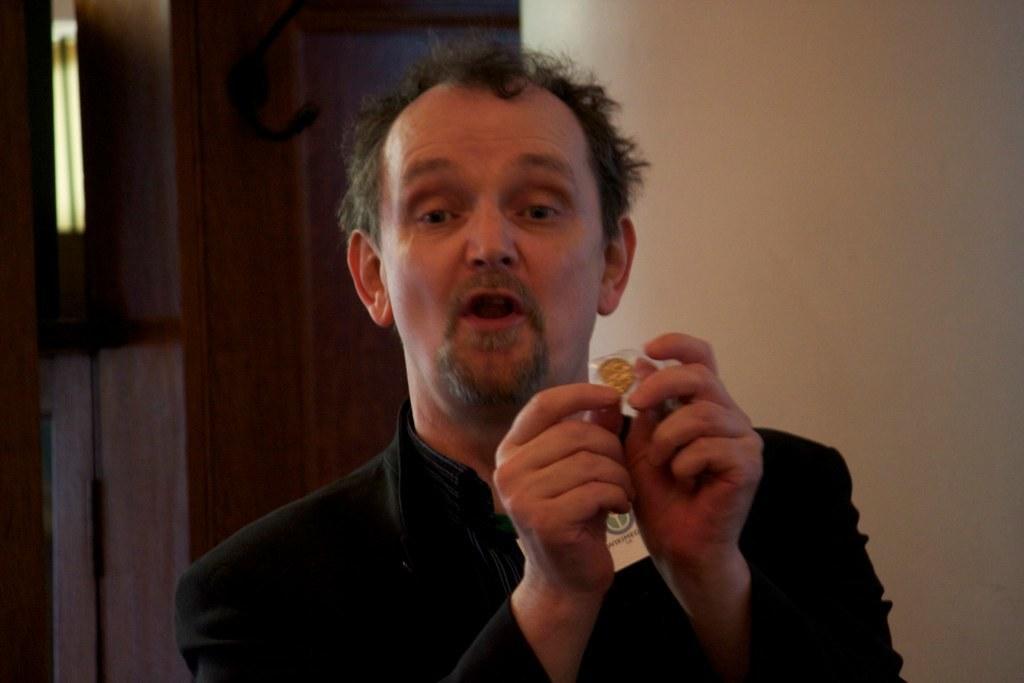Please provide a concise description of this image. In this image I can see a man and I can see he is wearing black colour dress. I can also see he is holding an object. 